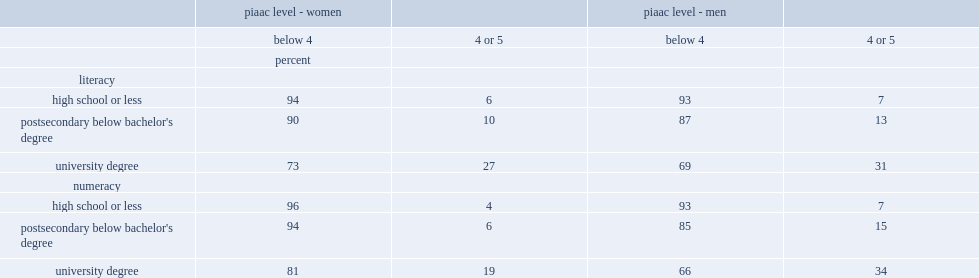What was the percentage of women with a university degree who scored at the highest literacy proficiency levels (4 or 5)? 27.0. What was the percentage of men with a university degree who had a proficiency level of 4 or 5 in literacy? 31.0. What was the percentage of men with a postsecondary below bachelor's degree who had a proficiency level of 4 or 5 in literacy? 13.0. Who had a lower percentage of those with a proficiency level of 4 or 5,women with a university degree in literacy or their male counterparts? Piaac level - women. What was the percentage of male university degree holders who had a proficiency level of 4 or 5 in numeracy ? 34.0. What was the percentage of women with a university degree who had a proficiency level of 4 or 5 in numeracy ? 19.0. 